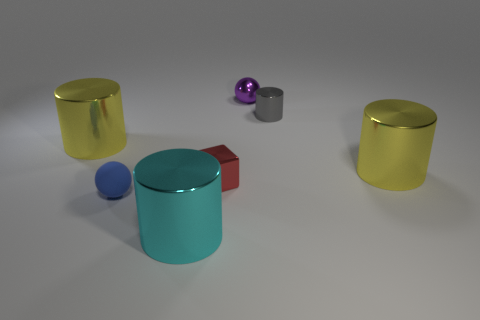What is the size of the yellow metal cylinder that is behind the big yellow object that is in front of the big yellow cylinder left of the small blue object?
Your answer should be compact. Large. Does the purple metallic thing have the same shape as the yellow metal object that is right of the small blue matte thing?
Give a very brief answer. No. Is there a cube of the same color as the small rubber thing?
Offer a terse response. No. How many cylinders are either blue objects or large objects?
Your answer should be very brief. 3. Is there a red object that has the same shape as the purple object?
Offer a very short reply. No. Are there fewer metallic things that are behind the tiny purple object than small blue metal cubes?
Provide a succinct answer. No. What number of big red matte blocks are there?
Offer a terse response. 0. How many small spheres are made of the same material as the blue object?
Make the answer very short. 0. How many things are either tiny shiny things that are behind the small gray thing or blue things?
Your answer should be very brief. 2. Are there fewer cylinders that are behind the tiny gray object than metallic spheres in front of the big cyan object?
Ensure brevity in your answer.  No. 